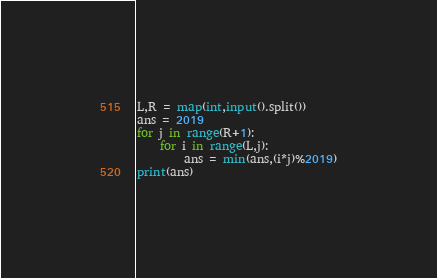Convert code to text. <code><loc_0><loc_0><loc_500><loc_500><_Python_>L,R = map(int,input().split())
ans = 2019
for j in range(R+1):
    for i in range(L,j):
        ans = min(ans,(i*j)%2019)
print(ans)</code> 